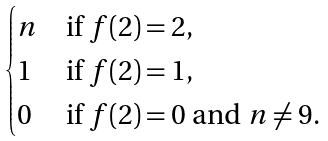<formula> <loc_0><loc_0><loc_500><loc_500>\begin{cases} n & \text {if } f ( 2 ) = 2 , \\ 1 & \text {if } f ( 2 ) = 1 , \\ 0 & \text {if } f ( 2 ) = 0 \text { and } n \ne 9 . \end{cases}</formula> 